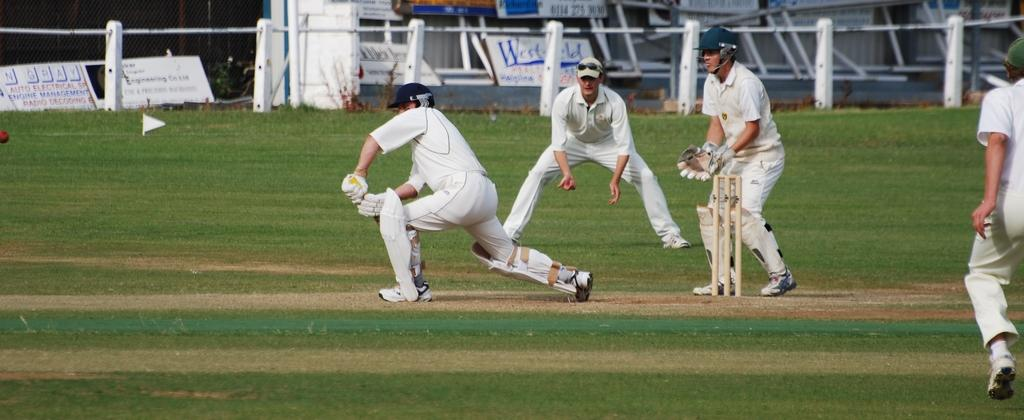What sport are the people playing in the image? The people are playing cricket in the image. Where is the cricket game taking place? The cricket game is taking place on a ground. What objects can be seen in the image besides the people playing cricket? There are metal rods visible in the image. What can be seen in the background of the image? There are banners in the background of the image. How many police officers are present in the image? There are no police officers present in the image; it features people playing cricket on a ground. What type of spiders can be seen crawling on the banners in the image? There are no spiders present in the image; it features banners in the background, but no spiders are visible. 